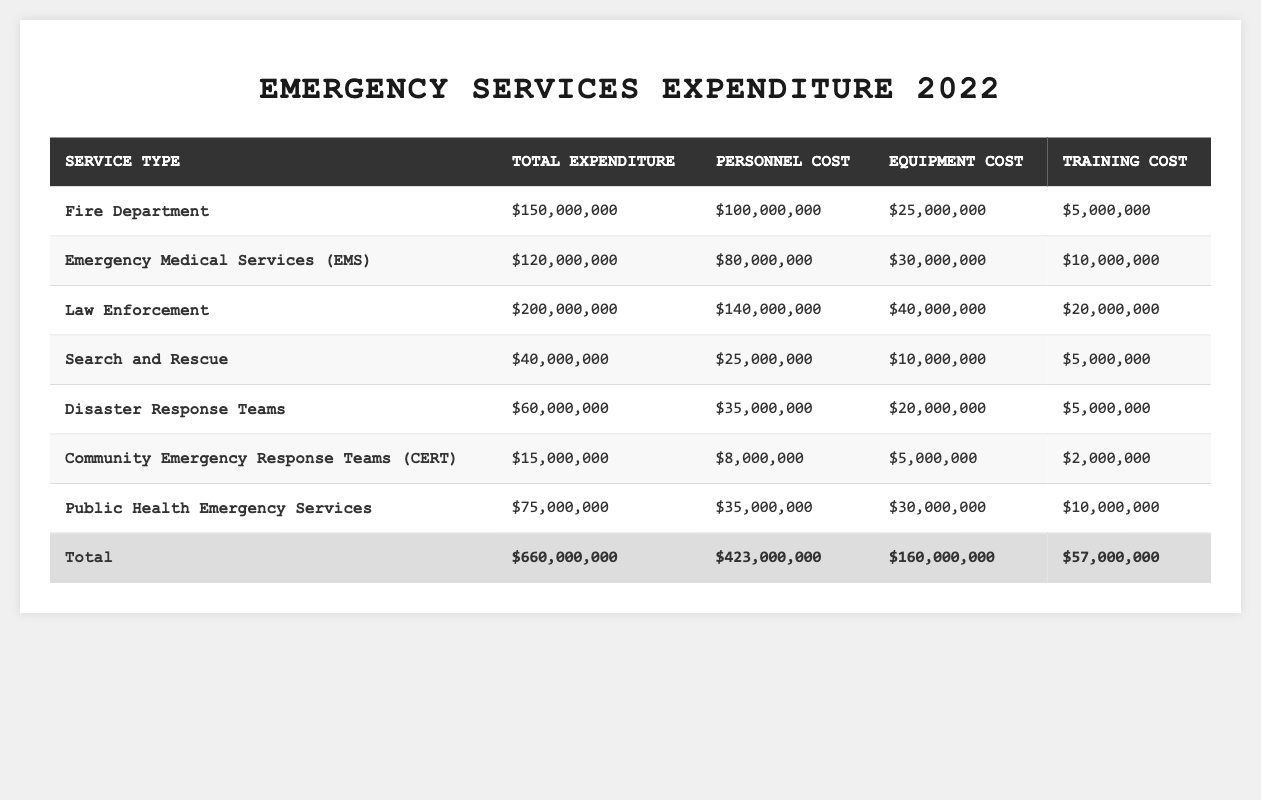What is the total expenditure on Emergency Medical Services (EMS)? The table shows that the total expenditure for Emergency Medical Services (EMS) is $120,000,000.
Answer: $120,000,000 What percentage of the total expenditure is spent on law enforcement? The total expenditure for all services is $660,000,000. The expenditure for law enforcement is $200,000,000. To find the percentage, divide $200,000,000 by $660,000,000 and multiply by 100, resulting in approximately 30.3%.
Answer: 30.3% Is the training cost for the Fire Department higher than that of Community Emergency Response Teams (CERT)? The training cost for the Fire Department is $5,000,000, and for CERT, it is $2,000,000. Since $5,000,000 is greater than $2,000,000, it is true that the Fire Department's training cost is higher.
Answer: Yes What is the total personnel cost for all emergency services? To find the total personnel cost, sum the personnel costs for each service: $100,000,000 + $80,000,000 + $140,000,000 + $25,000,000 + $35,000,000 + $8,000,000 + $35,000,000 = $423,000,000.
Answer: $423,000,000 Between Search and Rescue and Disaster Response Teams, which has a higher equipment cost? The equipment cost for Search and Rescue is $10,000,000 and for Disaster Response Teams is $20,000,000. Since $20,000,000 is greater, Disaster Response Teams has the higher equipment cost.
Answer: Disaster Response Teams What is the average training cost for all emergency services? The total training cost for all services is $57,000,000. Since there are 7 services listed, divide $57,000,000 by 7, resulting in approximately $8,142,857.
Answer: $8,142,857 Which service has the highest personnel cost and what is that cost? By reviewing the personnel costs, Law Enforcement has the highest personnel cost at $140,000,000.
Answer: $140,000,000 If the Fire Department and EMS expenditures are combined, what is the total? The expenditures for the Fire Department and EMS are $150,000,000 and $120,000,000 respectively. Summing these gives $150,000,000 + $120,000,000 = $270,000,000.
Answer: $270,000,000 How much is spent on equipment across all services compared to training? The total equipment cost sums to $160,000,000. The total training cost is $57,000,000. The difference is $160,000,000 - $57,000,000 = $103,000,000, so $103,000,000 more is spent on equipment.
Answer: $103,000,000 Is the total expenditure for Community Emergency Response Teams (CERT) less than that of Search and Rescue? The expenditure for CERT is $15,000,000, while for Search and Rescue, it is $40,000,000. Since $15,000,000 is less than $40,000,000, the statement is true.
Answer: Yes What is the ratio of personnel cost to total expenditure for Public Health Emergency Services? The personnel cost for Public Health Emergency Services is $35,000,000, and the total expenditure is $75,000,000. To find the ratio, divide $35,000,000 by $75,000,000, yielding a ratio of approximately 0.4667.
Answer: 0.4667 